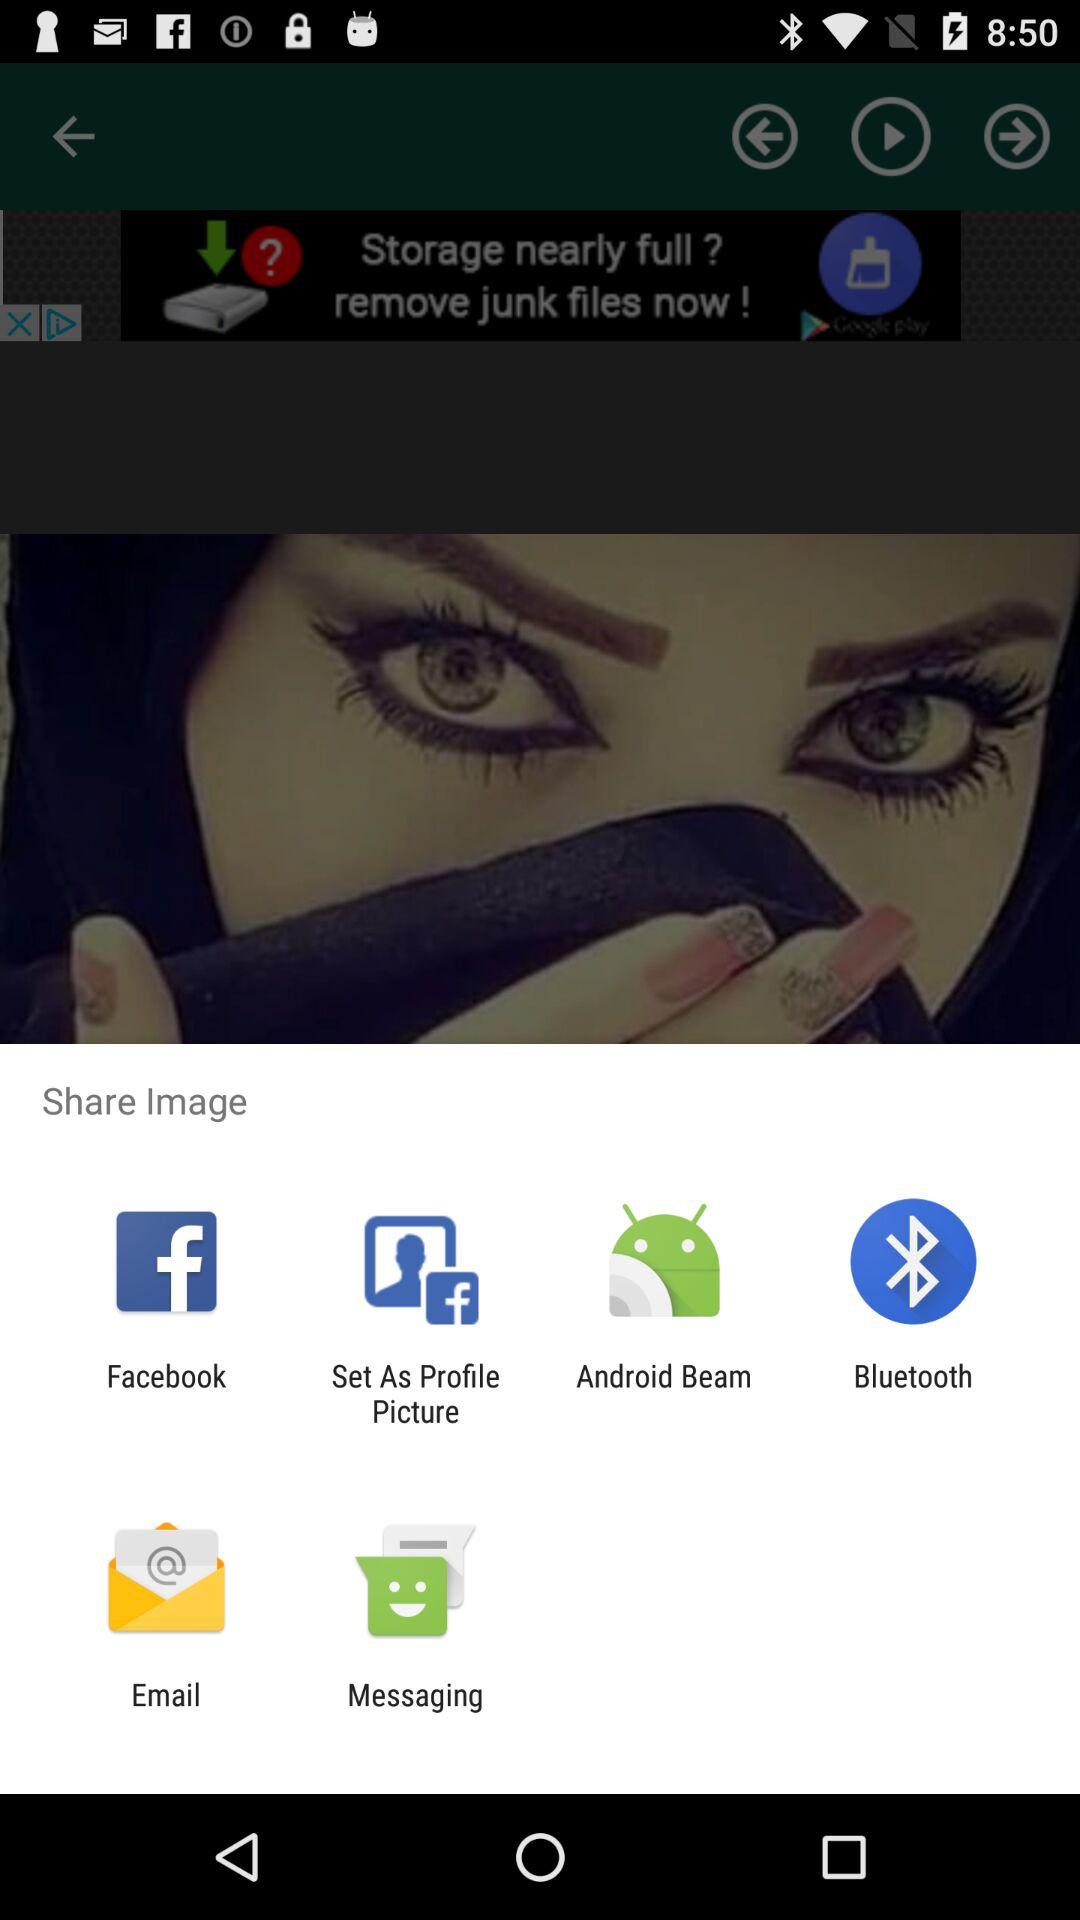What are the different applications through which we can share the image? The different applications through which we can share the image are "Facebook", "Set As Profile Picture", "Android Beam", "Bluetooth", "Email" and "Messaging". 